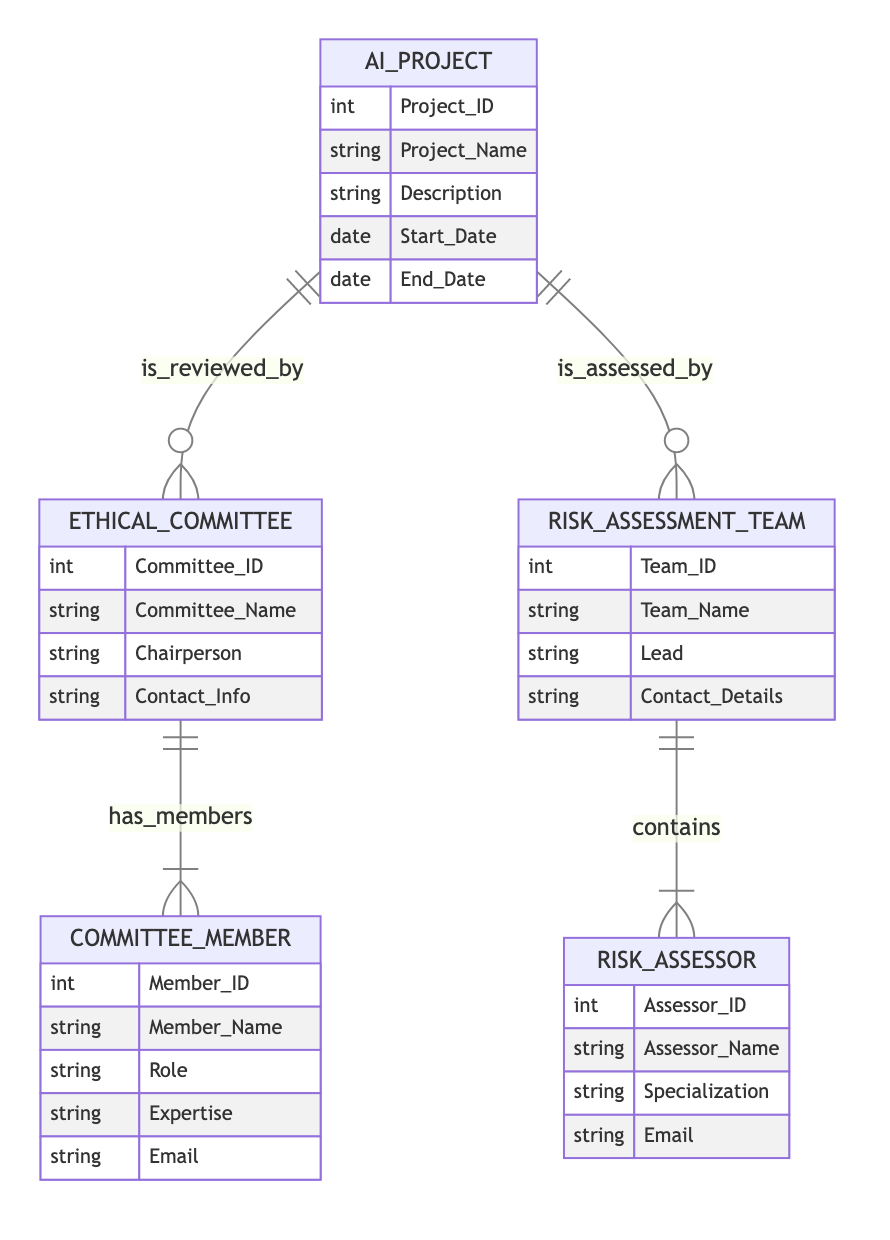What is the primary relationship between AI_Project and Ethical_Committee? The diagram shows that the AI_Project entity is reviewed by the Ethical_Committee, indicating a many-to-one relationship. This is represented by the notation where AI_Project has a line pointing to Ethical_Committee with the label "is_reviewed_by".
Answer: is_reviewed_by How many attributes does the Risk_Assessor entity have? The Risk_Assessor entity has 4 attributes listed: Assessor_ID, Assessor_Name, Specialization, and Email. Therefore, there are a total of 4 attributes associated with this entity.
Answer: 4 Which entity has a one-to-many relationship with Committee_Member? The Ethical_Committee has a one-to-many relationship with the Committee_Member, meaning that one Ethical_Committee can have multiple Committee_Members. This is indicated by the relationship labeled "has_members" pointing from Ethical_Committee to Committee_Member.
Answer: Ethical_Committee How many entities are there in the diagram? The diagram contains 5 entities: AI_Project, Ethical_Committee, Committee_Member, Risk_Assessment_Team, and Risk_Assessor. By counting the distinct entities presented, the total is 5.
Answer: 5 What is the role of the Risk_Assessment_Team in the diagram? The Risk_Assessment_Team assesses AI_Project and contains Risk_Assessor. This means that the team is responsible for evaluating the risks associated with AI projects and comprises individuals known as risk assessors, indicating its role in the ethical review process.
Answer: assesses What does the Committee_Member belong to? Each Committee_Member belongs to an Ethical_Committee, as represented by the many-to-one relationship labeled "belongs_to". This defines the hierarchical structure where multiple members can be a part of a single committee.
Answer: Ethical_Committee Which attribute identifies the Ethical_Committee? The Committee_ID is the unique identifier for the Ethical_Committee entity, as indicated in the attributes list. This attribute ensures each committee can be distinctly recognized.
Answer: Committee_ID How many risk assessors can be part of a Risk_Assessment_Team? The relationship labeled "contains" indicates that a Risk_Assessment_Team can have many Risk_Assessors. Therefore, there is no upper limit defined in the diagram for the number of assessors in a team, but it is at least one.
Answer: many What type of relationship exists between AI_Project and Risk_Assessment_Team? The relationship between AI_Project and Risk_Assessment_Team is many-to-one, as indicated by the notation in the diagram. This means multiple AI projects can be assessed by one risk assessment team.
Answer: is_assessed_by 